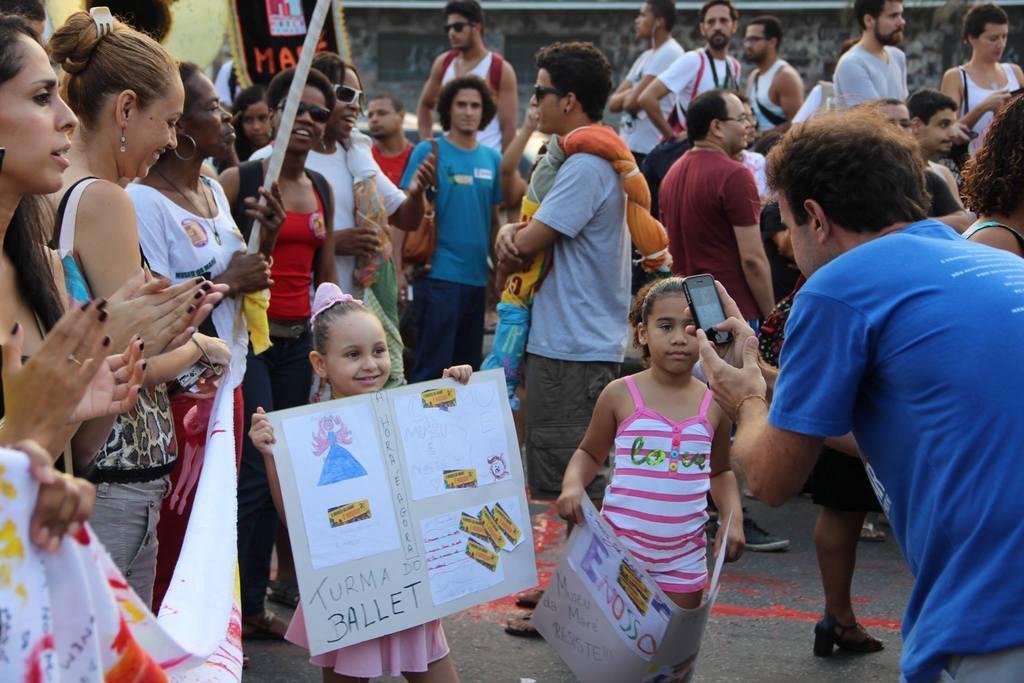Could you give a brief overview of what you see in this image? This picture describes about group of people, few people wore spectacles and few people holding placards, on the right side of the image we can see a man he is holding a mobile. 